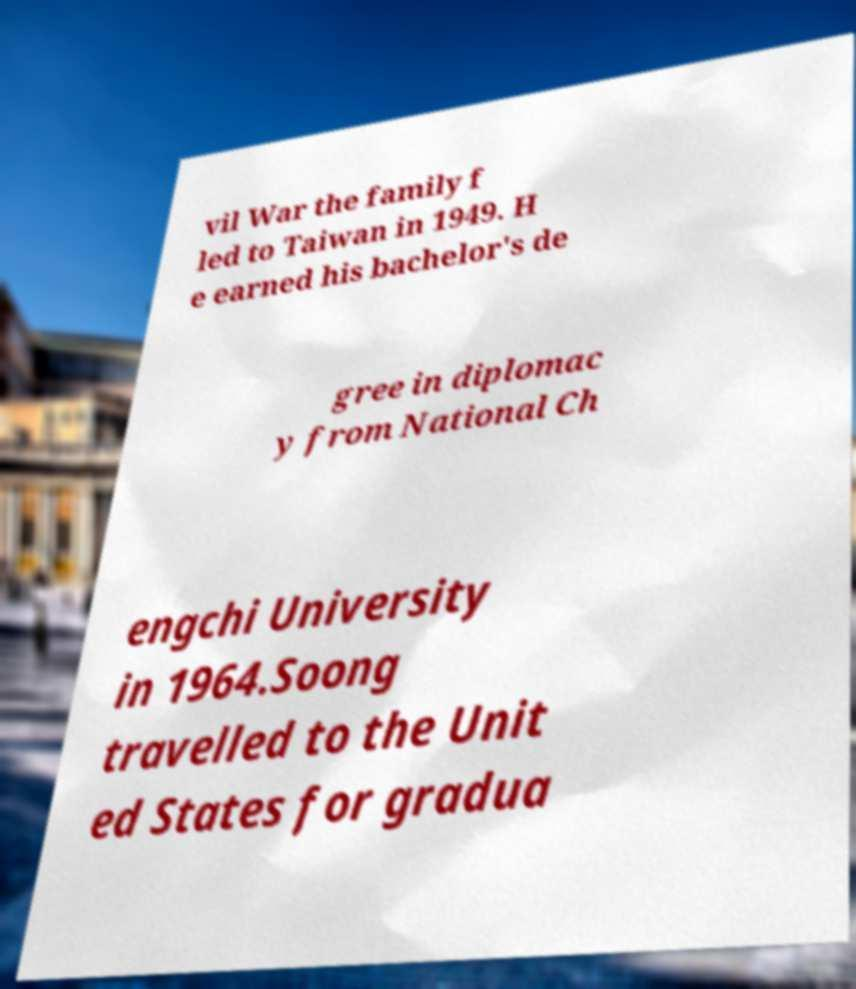Can you accurately transcribe the text from the provided image for me? vil War the family f led to Taiwan in 1949. H e earned his bachelor's de gree in diplomac y from National Ch engchi University in 1964.Soong travelled to the Unit ed States for gradua 